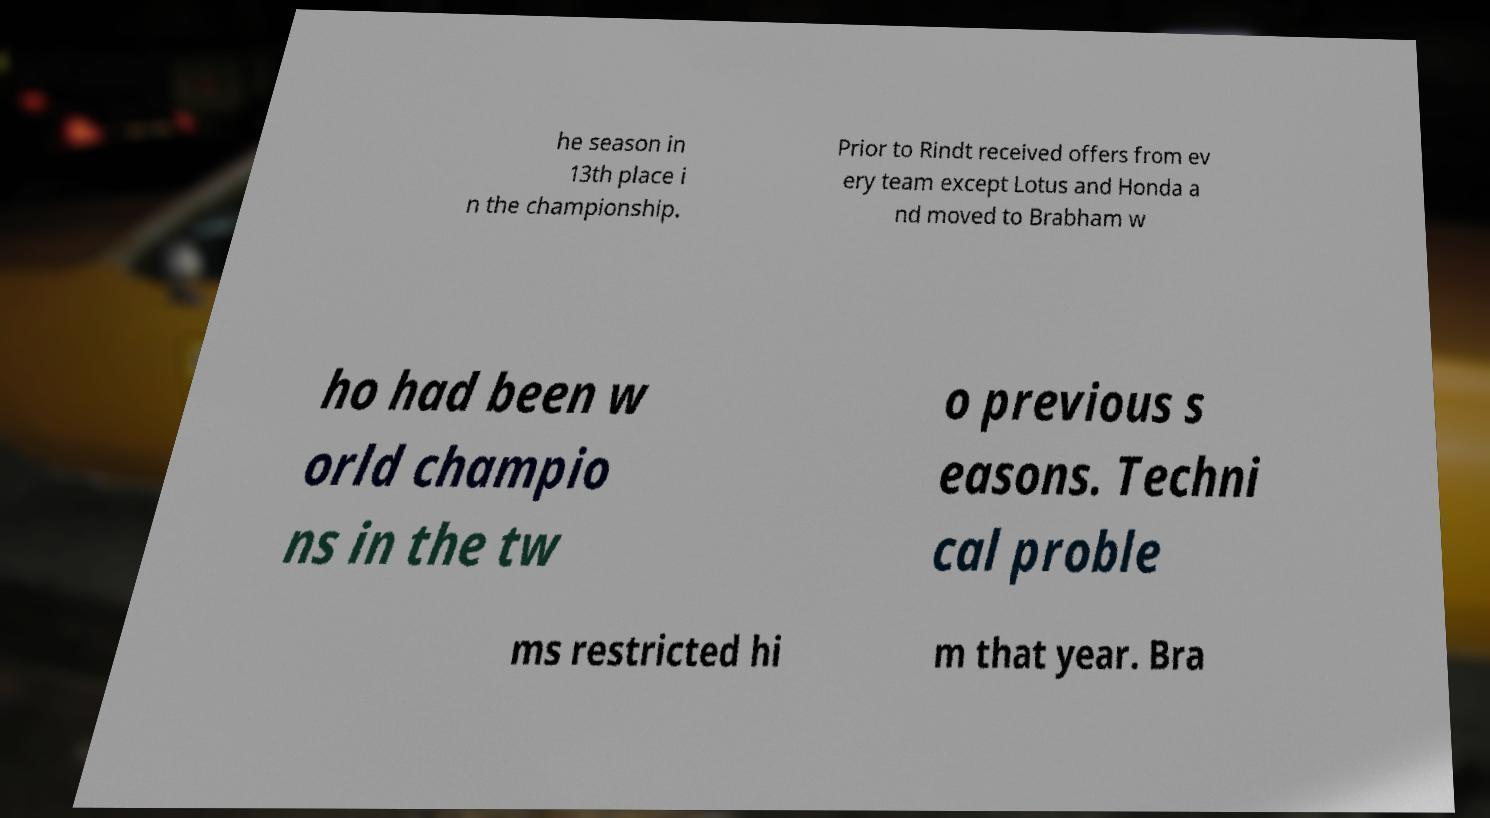Can you accurately transcribe the text from the provided image for me? he season in 13th place i n the championship. Prior to Rindt received offers from ev ery team except Lotus and Honda a nd moved to Brabham w ho had been w orld champio ns in the tw o previous s easons. Techni cal proble ms restricted hi m that year. Bra 